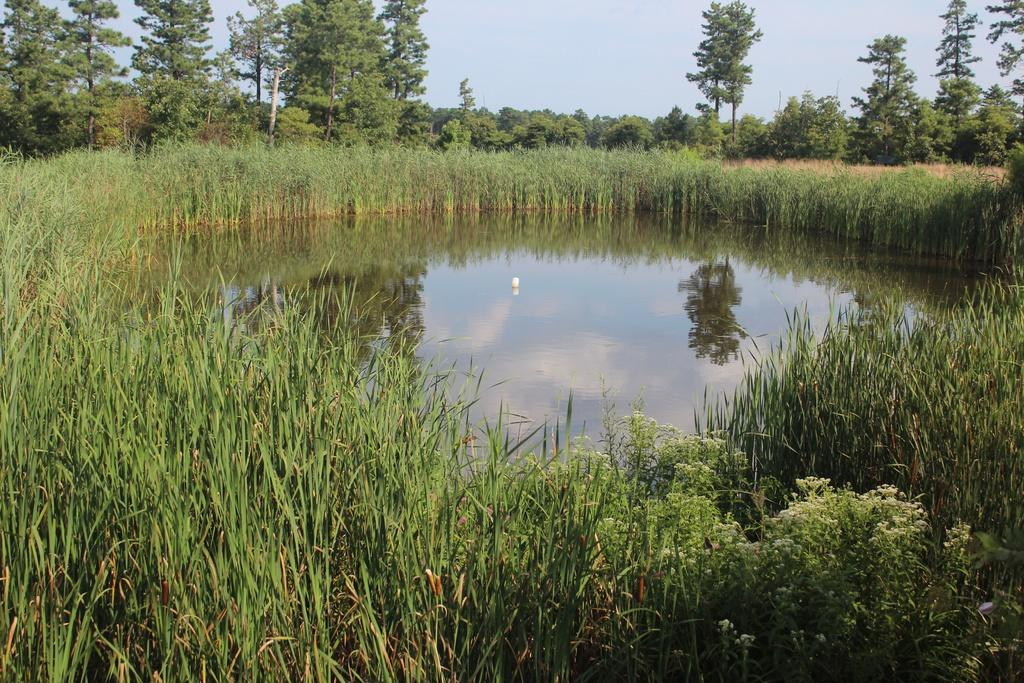What type of vegetation can be seen in the image? There are bushes and trees in the image. What natural element is visible in the image? Water is visible in the image. What can be seen in the background of the image? The sky is visible in the background of the image. What is reflected in the water in the image? There is a reflection of trees in the water. What type of apple is being used as a veil in the image? There is no apple or veil present in the image. How many rails can be seen in the image? There are no rails visible in the image. 